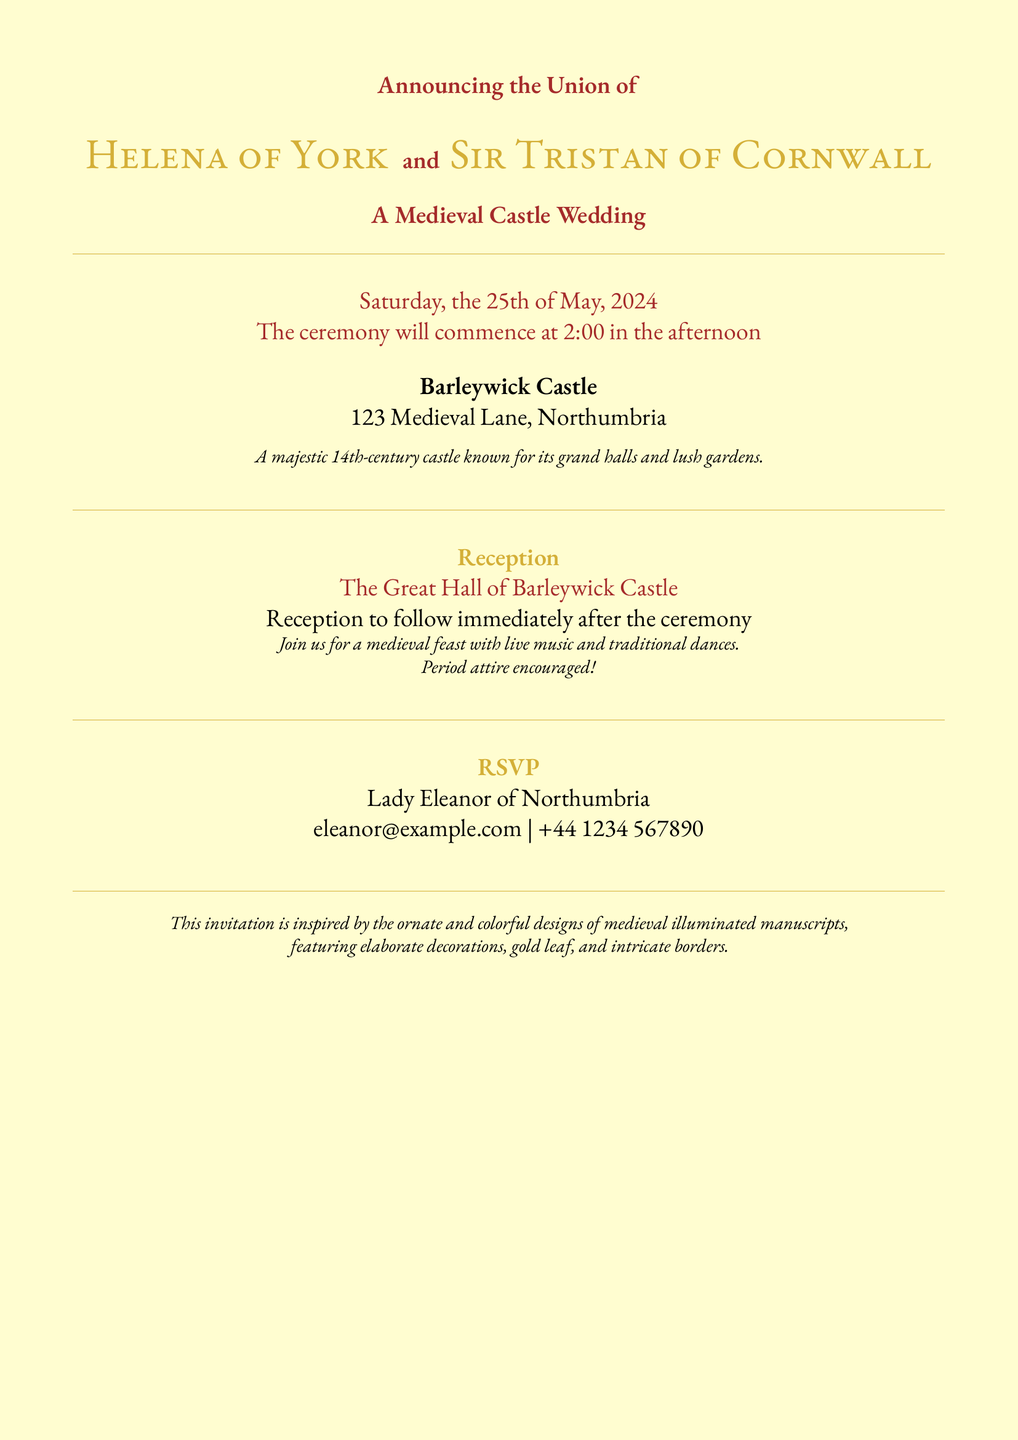What is the date of the wedding? The date is explicitly mentioned in the document, which states "Saturday, the 25th of May, 2024."
Answer: 25th of May, 2024 Who are the couple getting married? The document introduces the couple by name, identifying them as "Helena of York" and "Sir Tristan of Cornwall."
Answer: Helena of York and Sir Tristan of Cornwall What time does the ceremony start? The document specifies the start time, stating "The ceremony will commence at 2:00 in the afternoon."
Answer: 2:00 in the afternoon What is the location of the reception? The location for the reception is clearly stated as "The Great Hall of Barleywick Castle."
Answer: The Great Hall of Barleywick Castle What type of attire is encouraged for the guests? The invitation includes a note suggesting "Period attire encouraged!" for the attendees.
Answer: Period attire What is the RSVP contact person's title? The document indicates that the RSVP contact person's title is "Lady."
Answer: Lady How is the castle described in the invitation? A brief description of the castle is provided, stating it is "A majestic 14th-century castle known for its grand halls and lush gardens."
Answer: A majestic 14th-century castle known for its grand halls and lush gardens What type of event follows the wedding ceremony? The document specifies a type of celebration that will take place after the ceremony, described as a "medieval feast with live music and traditional dances."
Answer: medieval feast with live music and traditional dances 